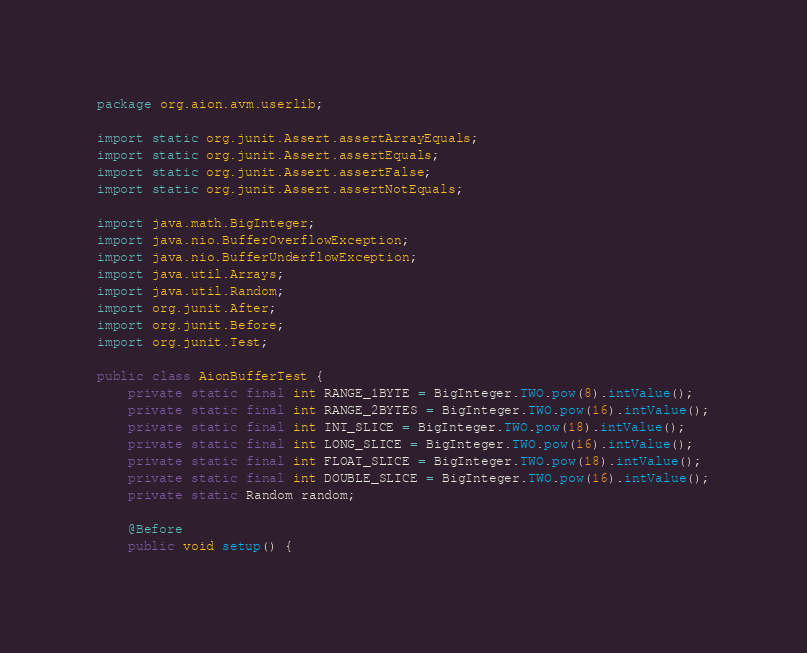<code> <loc_0><loc_0><loc_500><loc_500><_Java_>package org.aion.avm.userlib;

import static org.junit.Assert.assertArrayEquals;
import static org.junit.Assert.assertEquals;
import static org.junit.Assert.assertFalse;
import static org.junit.Assert.assertNotEquals;

import java.math.BigInteger;
import java.nio.BufferOverflowException;
import java.nio.BufferUnderflowException;
import java.util.Arrays;
import java.util.Random;
import org.junit.After;
import org.junit.Before;
import org.junit.Test;

public class AionBufferTest {
    private static final int RANGE_1BYTE = BigInteger.TWO.pow(8).intValue();
    private static final int RANGE_2BYTES = BigInteger.TWO.pow(16).intValue();
    private static final int INT_SLICE = BigInteger.TWO.pow(18).intValue();
    private static final int LONG_SLICE = BigInteger.TWO.pow(16).intValue();
    private static final int FLOAT_SLICE = BigInteger.TWO.pow(18).intValue();
    private static final int DOUBLE_SLICE = BigInteger.TWO.pow(16).intValue();
    private static Random random;

    @Before
    public void setup() {</code> 